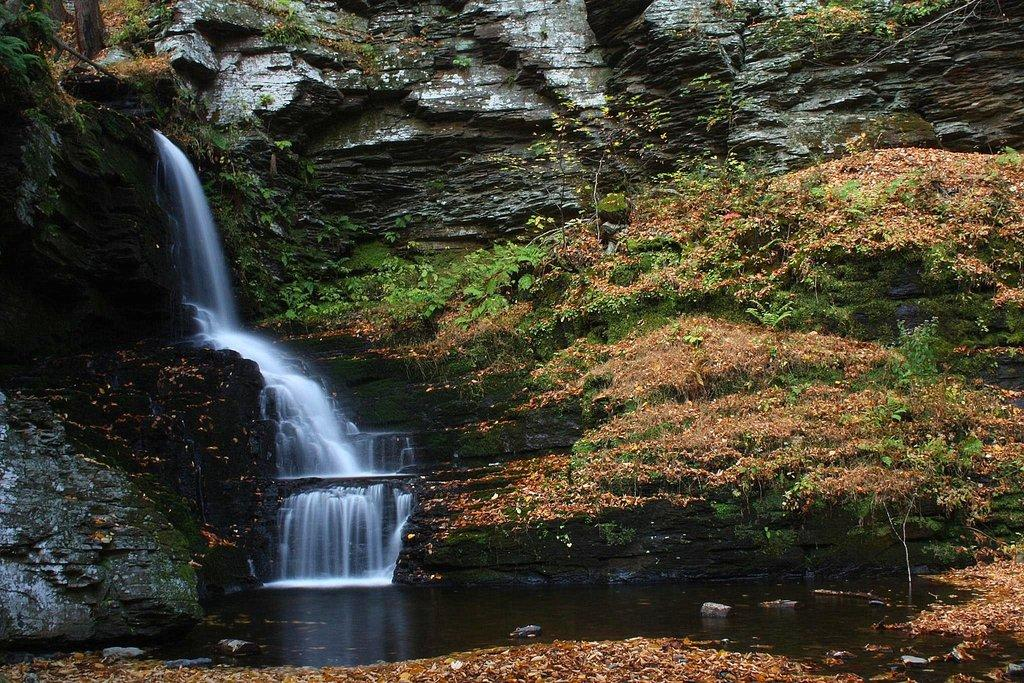What type of geological formation can be seen in the image? There are rock hills in the image. What natural feature is present in the image? There is a waterfall in the image. What type of vegetation is visible in the image? There are plants in the image. What is visible beneath the plants and waterfall? The ground is visible in the image. What type of debris can be seen on the ground? There are dried leaves on the ground. What type of leaf is causing shame in the image? There is no indication of shame or any specific type of leaf causing it in the image. 